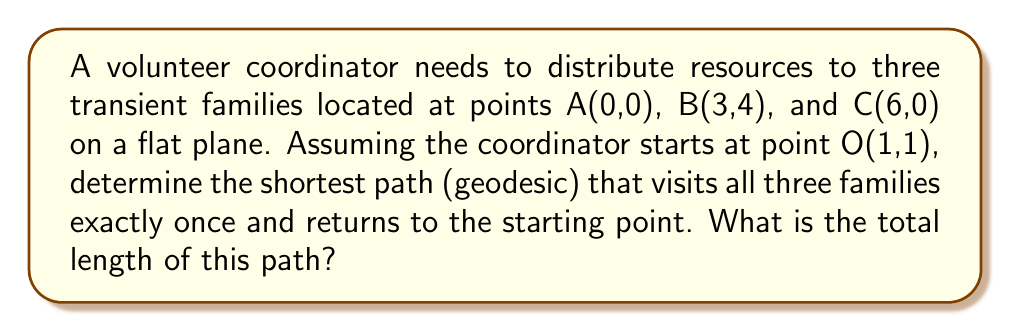Can you answer this question? To solve this problem, we'll follow these steps:

1) In a flat plane, the geodesic (shortest path) between two points is a straight line. Therefore, we need to find the shortest path that connects all points in a loop.

2) This is equivalent to solving the Traveling Salesman Problem for 4 points (including the starting point).

3) For 4 points, there are 3! = 6 possible paths. We need to calculate the length of each and find the shortest.

4) The distance between two points $(x_1,y_1)$ and $(x_2,y_2)$ is given by:

   $$d = \sqrt{(x_2-x_1)^2 + (y_2-y_1)^2}$$

5) Let's calculate the distances:
   OA = $\sqrt{(0-1)^2 + (0-1)^2} = \sqrt{2}$
   OB = $\sqrt{(3-1)^2 + (4-1)^2} = \sqrt{13}$
   OC = $\sqrt{(6-1)^2 + (0-1)^2} = \sqrt{26}$
   AB = $\sqrt{(3-0)^2 + (4-0)^2} = 5$
   BC = $\sqrt{(6-3)^2 + (0-4)^2} = 5$
   AC = 6

6) Now, let's calculate the length of each possible path:
   OABCO: $\sqrt{2} + 5 + 5 + \sqrt{26} = 10 + \sqrt{2} + \sqrt{26}$
   OACBO: $\sqrt{2} + 6 + 5 + \sqrt{13} = 11 + \sqrt{2} + \sqrt{13}$
   OBACO: $\sqrt{13} + 5 + 6 + \sqrt{2} = 11 + \sqrt{13} + \sqrt{2}$
   OBCAO: $\sqrt{13} + 5 + 6 + \sqrt{2} = 11 + \sqrt{13} + \sqrt{2}$
   OCABO: $\sqrt{26} + 6 + 5 + \sqrt{2} = 11 + \sqrt{26} + \sqrt{2}$
   OCBAO: $\sqrt{26} + 5 + 5 + \sqrt{2} = 10 + \sqrt{26} + \sqrt{2}$

7) The shortest path is OABCO or OCBAO, both with length $10 + \sqrt{2} + \sqrt{26}$.
Answer: $10 + \sqrt{2} + \sqrt{26}$ 